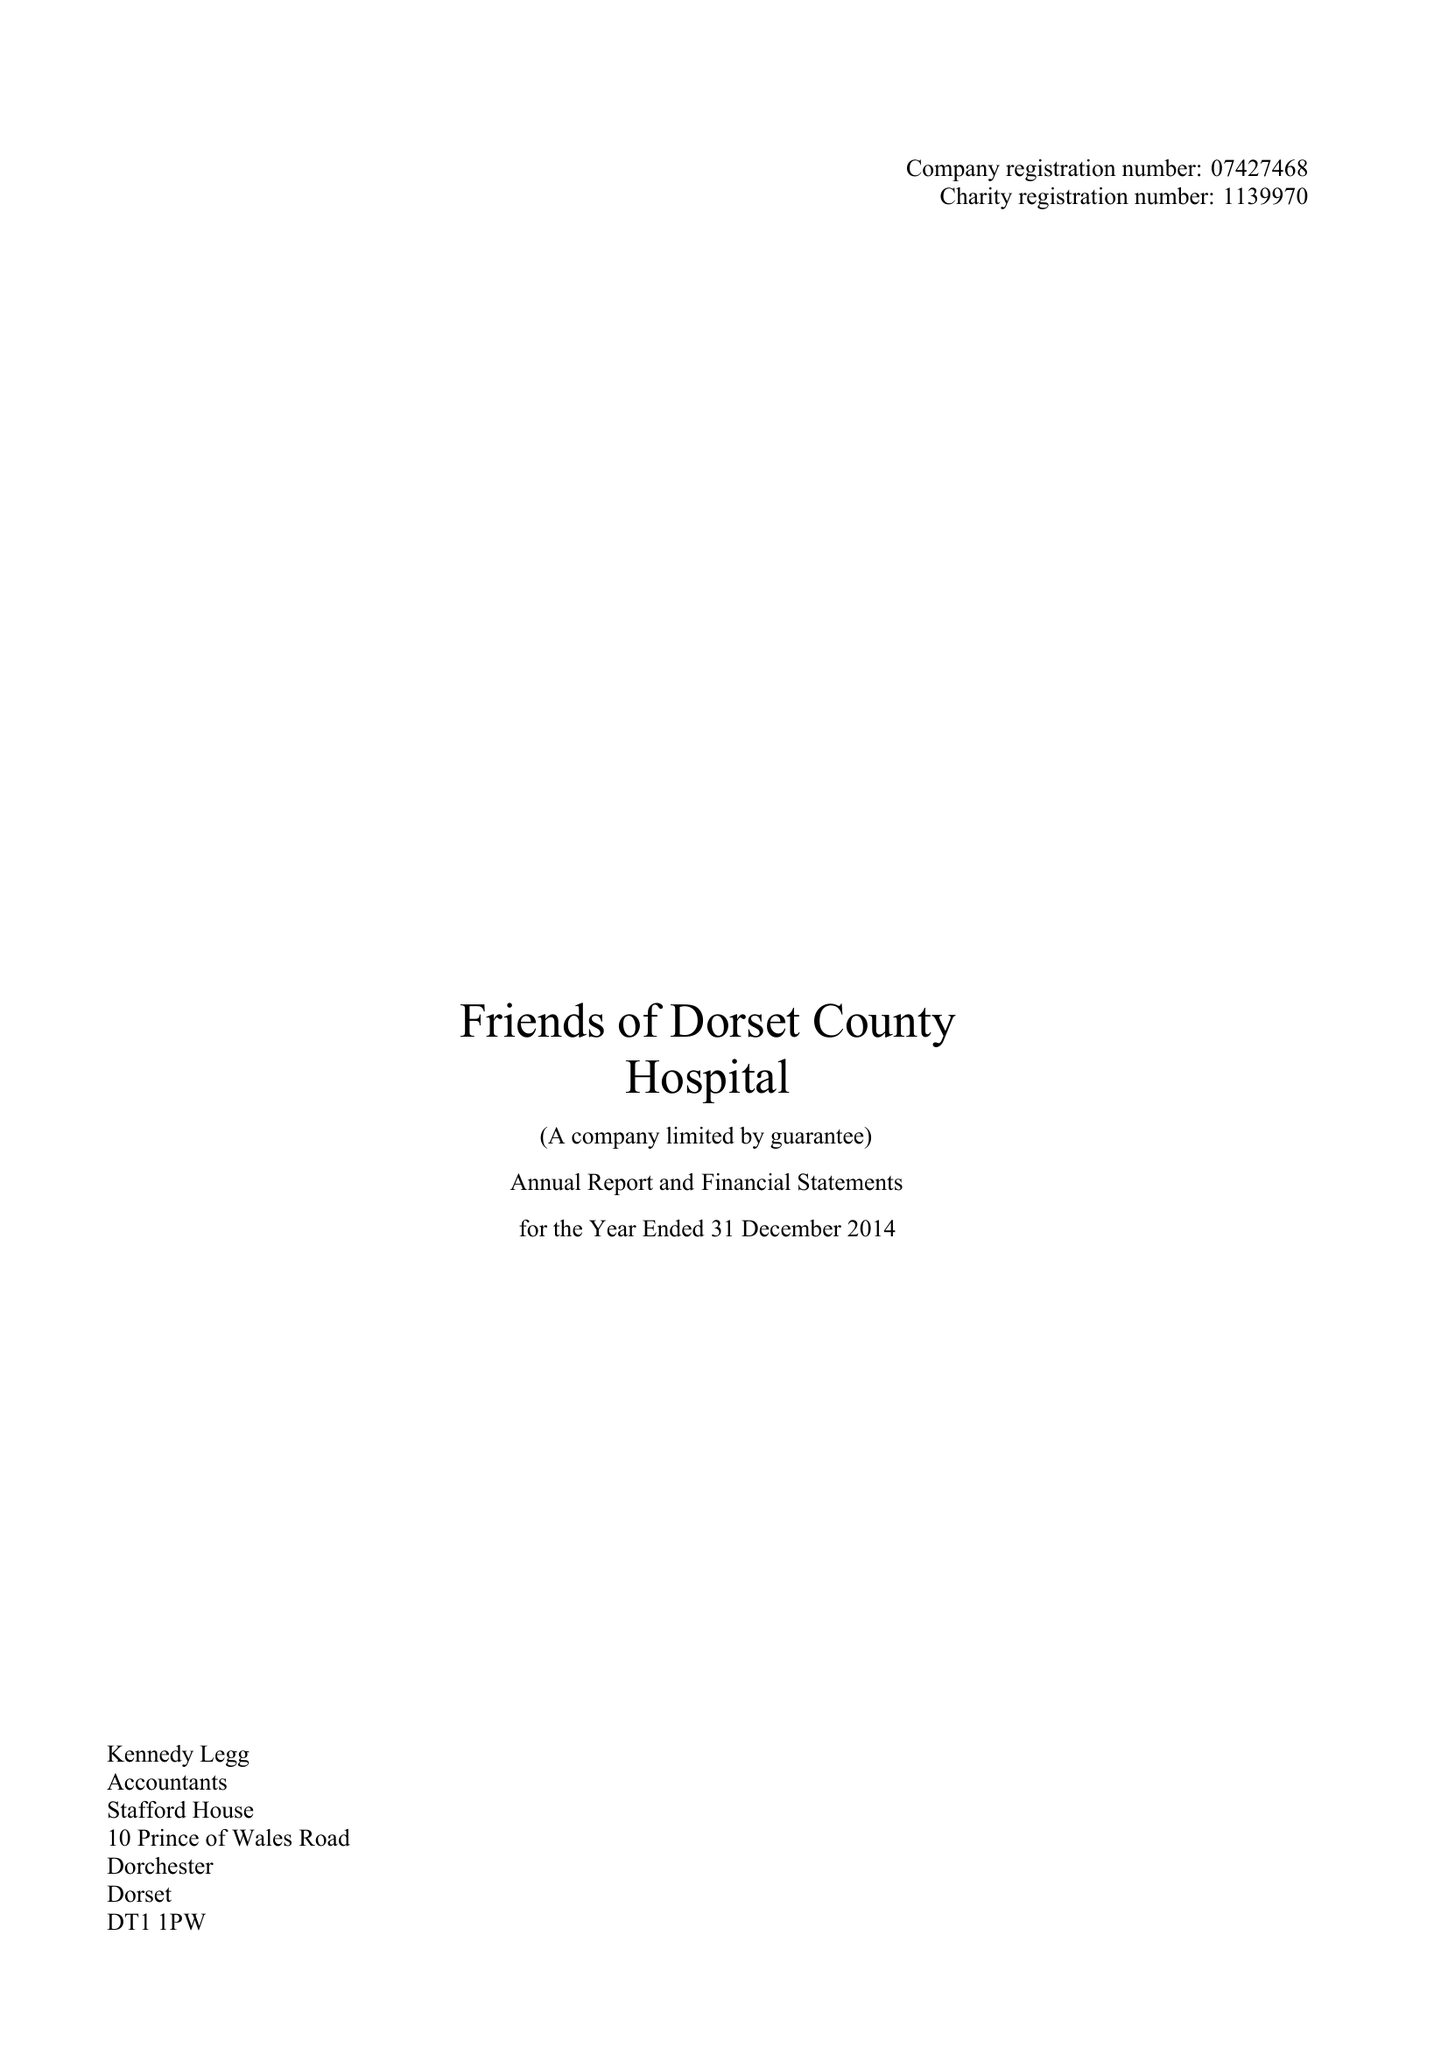What is the value for the spending_annually_in_british_pounds?
Answer the question using a single word or phrase. 127187.00 